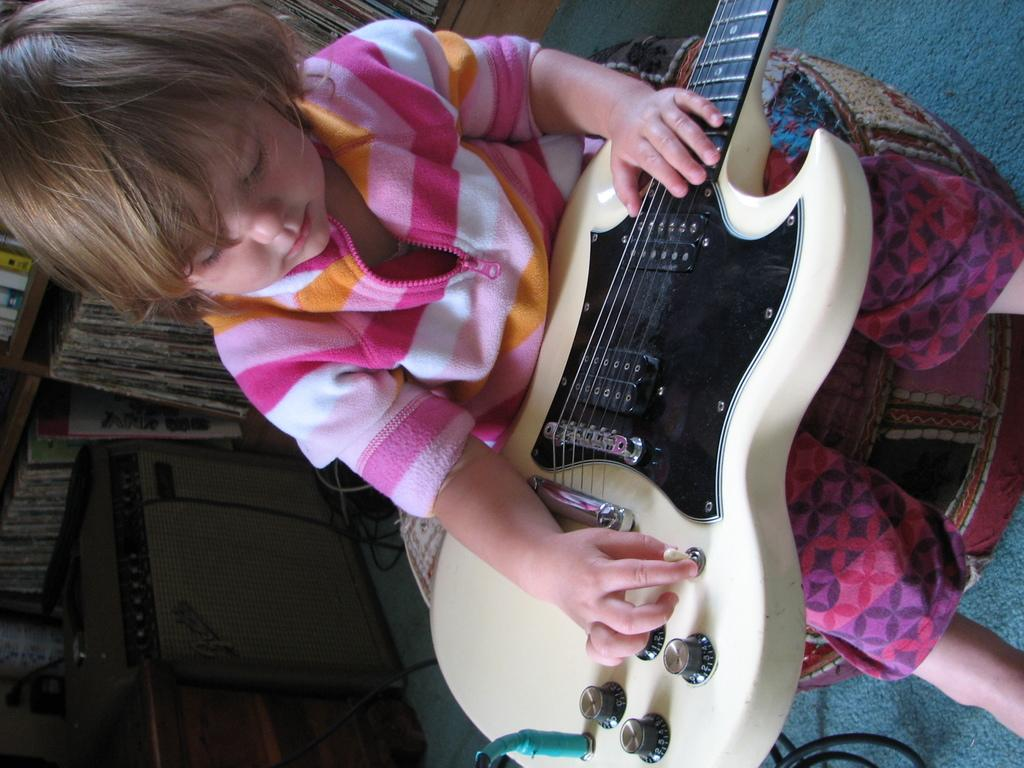What is the main subject of the image? There is a child in the image. What is the child holding in the image? The child is holding a musical instrument. What can be seen in the background of the image? There are books in the background of the image. How are the books arranged in the image? The books are in racks. What grade does the tiger receive for its performance in the image? There is no tiger present in the image, so it cannot receive a grade for its performance. 